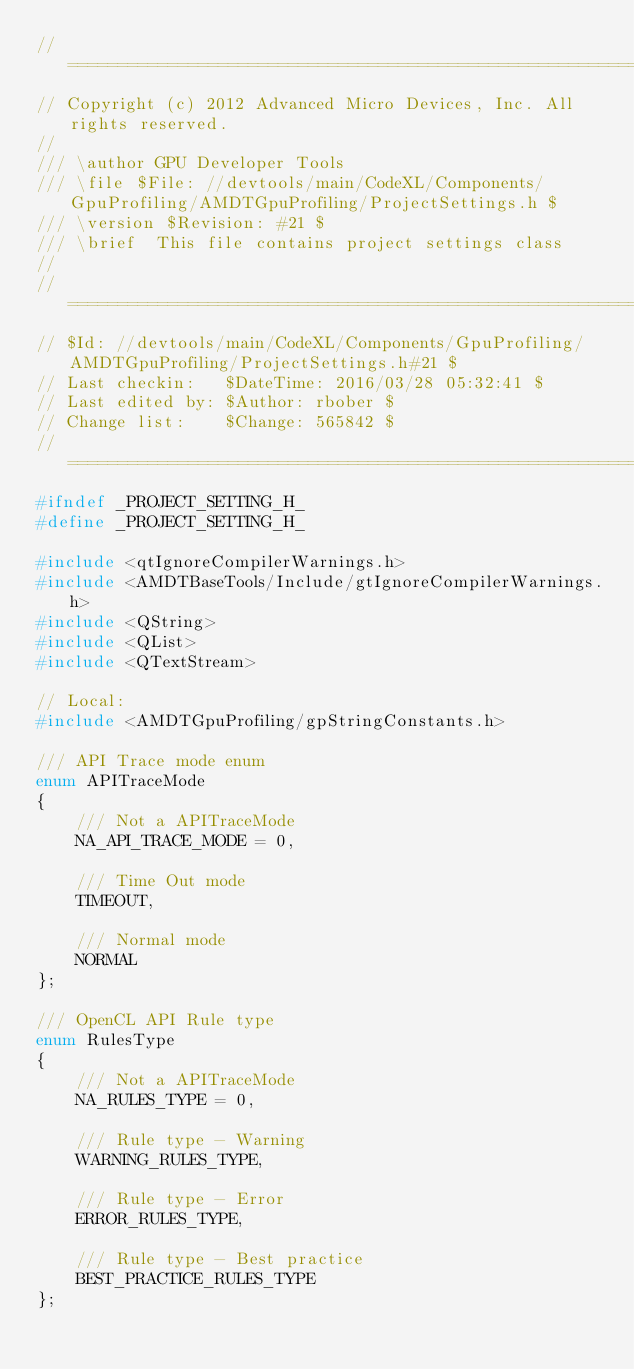Convert code to text. <code><loc_0><loc_0><loc_500><loc_500><_C_>//=====================================================================
// Copyright (c) 2012 Advanced Micro Devices, Inc. All rights reserved.
//
/// \author GPU Developer Tools
/// \file $File: //devtools/main/CodeXL/Components/GpuProfiling/AMDTGpuProfiling/ProjectSettings.h $
/// \version $Revision: #21 $
/// \brief  This file contains project settings class
//
//=====================================================================
// $Id: //devtools/main/CodeXL/Components/GpuProfiling/AMDTGpuProfiling/ProjectSettings.h#21 $
// Last checkin:   $DateTime: 2016/03/28 05:32:41 $
// Last edited by: $Author: rbober $
// Change list:    $Change: 565842 $
//=====================================================================
#ifndef _PROJECT_SETTING_H_
#define _PROJECT_SETTING_H_

#include <qtIgnoreCompilerWarnings.h>
#include <AMDTBaseTools/Include/gtIgnoreCompilerWarnings.h>
#include <QString>
#include <QList>
#include <QTextStream>

// Local:
#include <AMDTGpuProfiling/gpStringConstants.h>

/// API Trace mode enum
enum APITraceMode
{
    /// Not a APITraceMode
    NA_API_TRACE_MODE = 0,

    /// Time Out mode
    TIMEOUT,

    /// Normal mode
    NORMAL
};

/// OpenCL API Rule type
enum RulesType
{
    /// Not a APITraceMode
    NA_RULES_TYPE = 0,

    /// Rule type - Warning
    WARNING_RULES_TYPE,

    /// Rule type - Error
    ERROR_RULES_TYPE,

    /// Rule type - Best practice
    BEST_PRACTICE_RULES_TYPE
};
</code> 